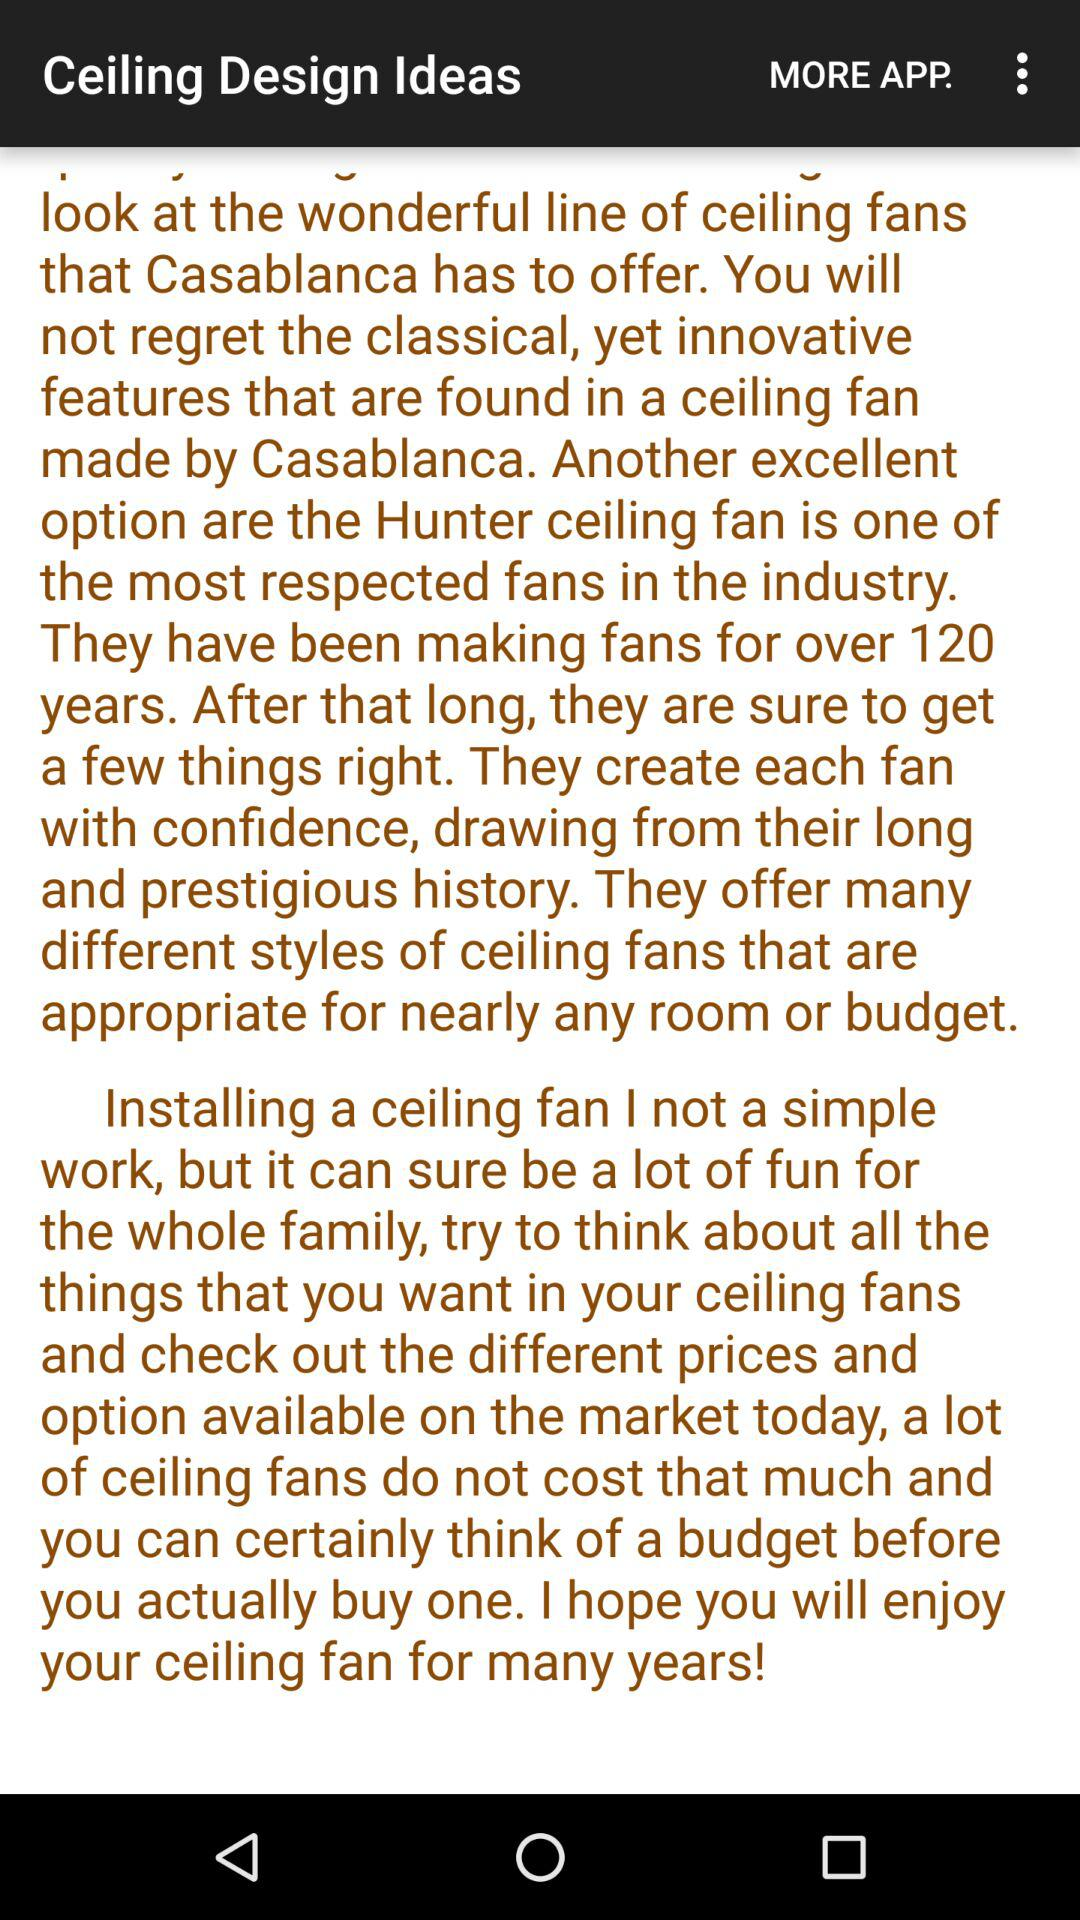What is the application name? The application name is "Ceiling Design Ideas". 